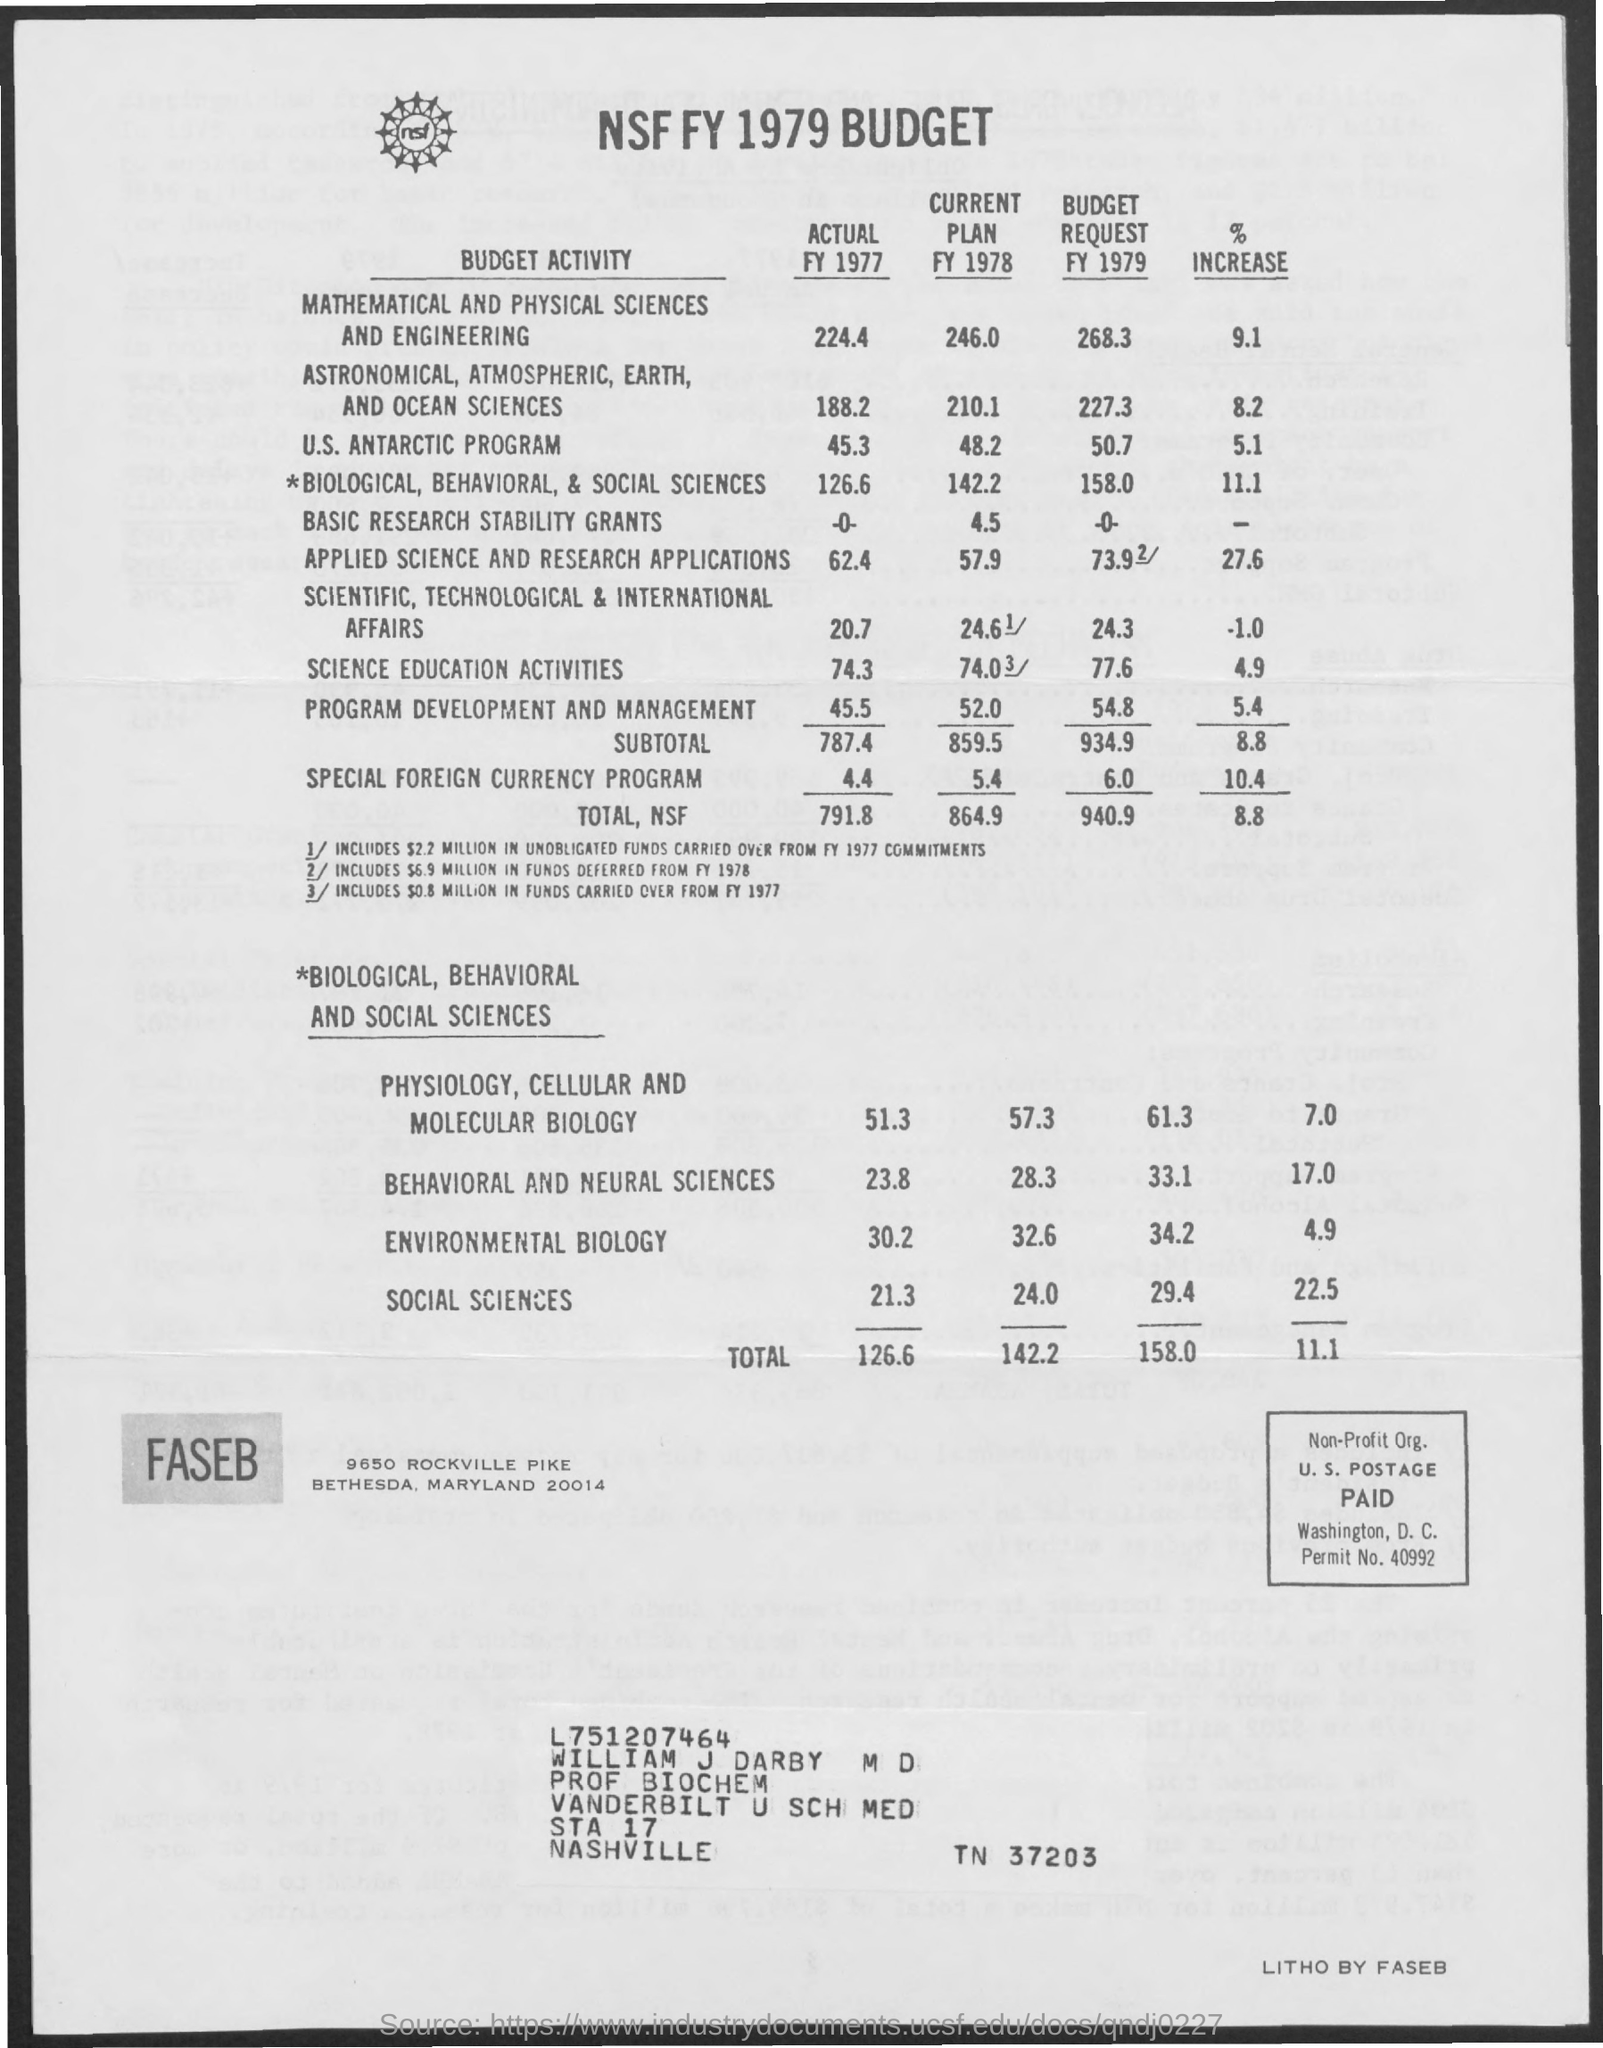Which budget is this?
Your answer should be very brief. NSF FY 1979 Budget. What is the total actual budget during FY 1977?
Ensure brevity in your answer.  791.8. What is total budget request FY 1979?
Your answer should be very brief. 940.9. What is the % increase of Total budget?
Make the answer very short. 8.8. For which budget activity highest budget is allocated in FY 1977?
Keep it short and to the point. MATHEMATICAL AND PHYSICAL SCIENCES AND ENGINEERING. What is the budget for Special Foreign currency program in FY 1978?
Keep it short and to the point. 5.4. 